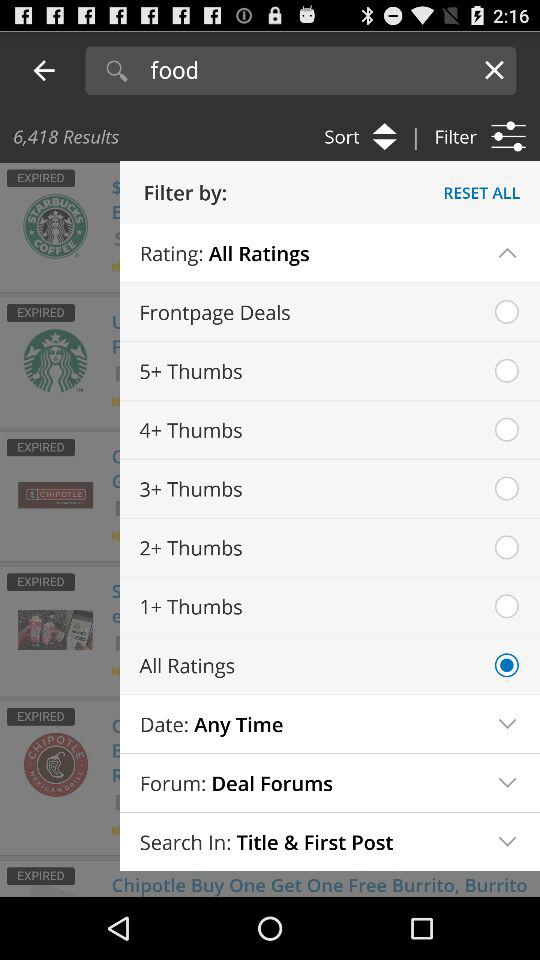How many results have been shown? There are 6,418 results shown. 